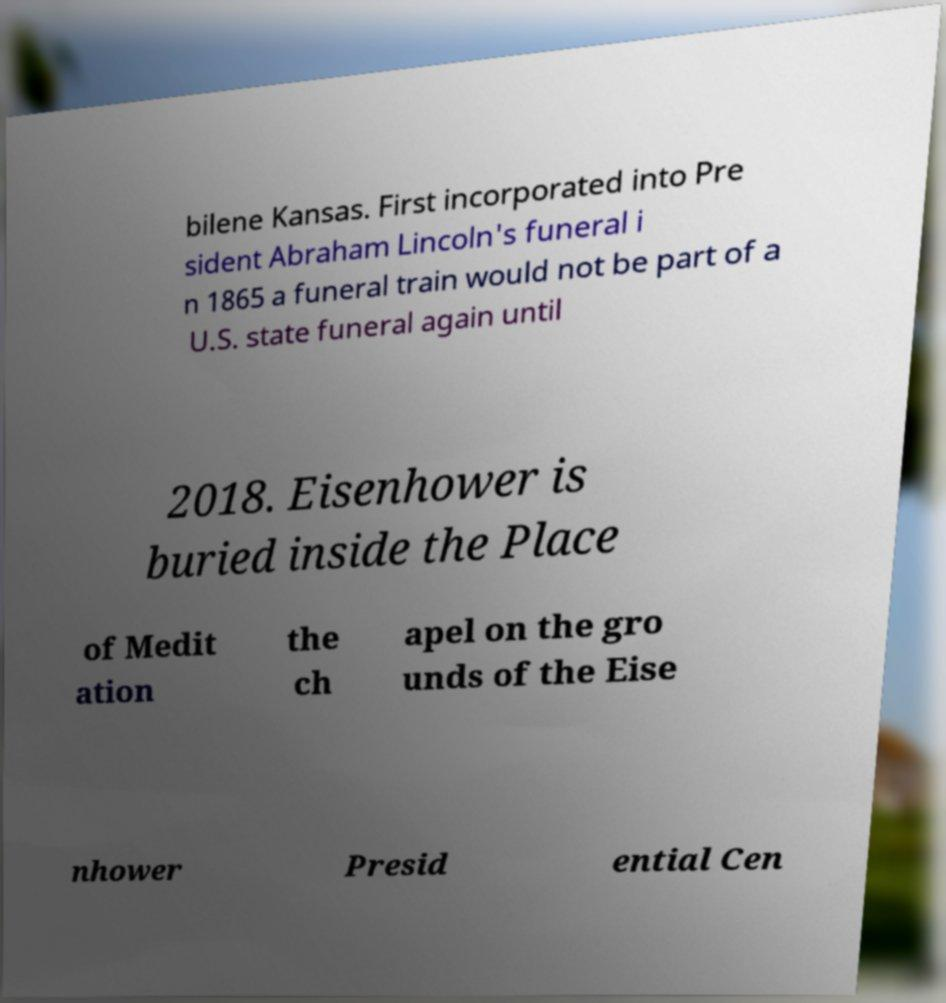What messages or text are displayed in this image? I need them in a readable, typed format. bilene Kansas. First incorporated into Pre sident Abraham Lincoln's funeral i n 1865 a funeral train would not be part of a U.S. state funeral again until 2018. Eisenhower is buried inside the Place of Medit ation the ch apel on the gro unds of the Eise nhower Presid ential Cen 